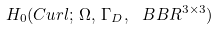Convert formula to latex. <formula><loc_0><loc_0><loc_500><loc_500>H _ { 0 } ( C u r l ; \, \Omega , \, \Gamma _ { D } , \ B B R ^ { 3 \times 3 } )</formula> 